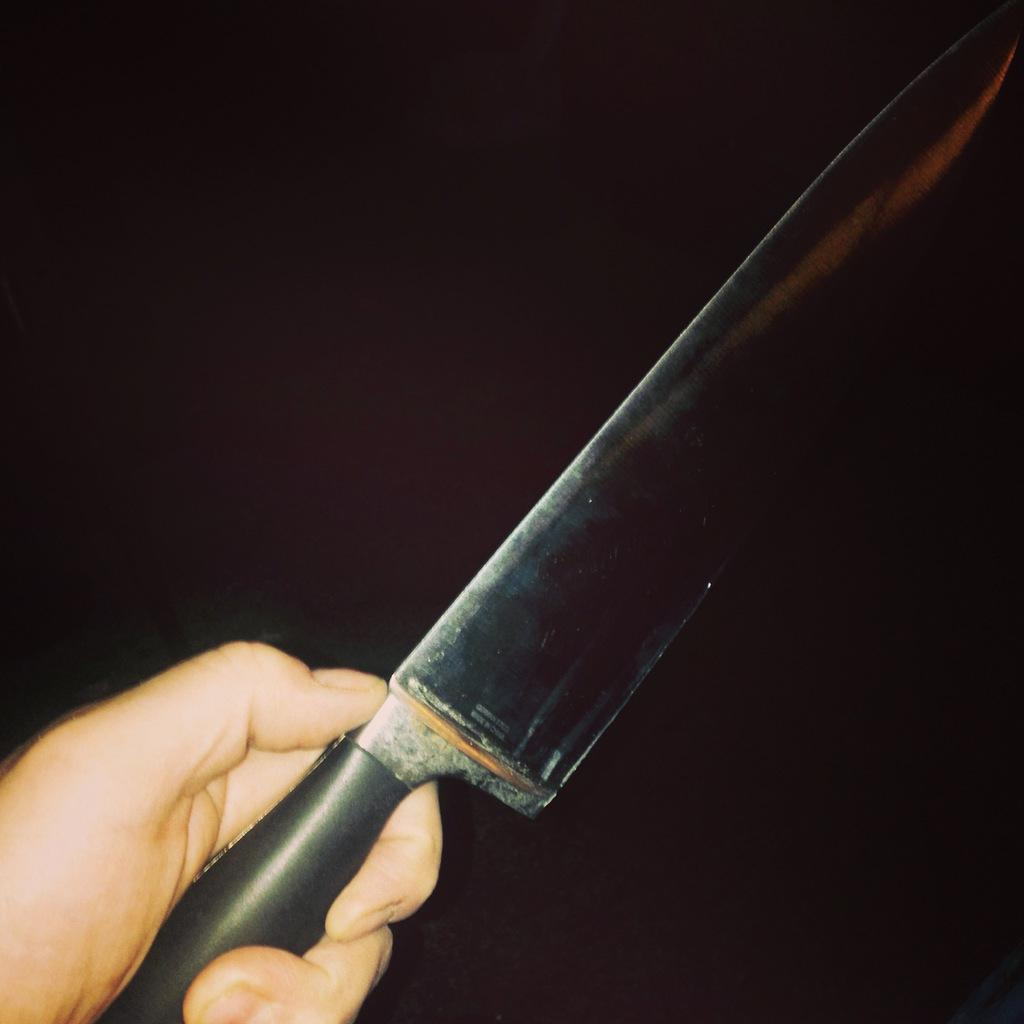What is present in the image? There is a person in the image. What is the person holding? The person is holding a knife. What type of fruit is the person cutting with the knife in the image? There is no fruit present in the image; the person is only holding a knife. 